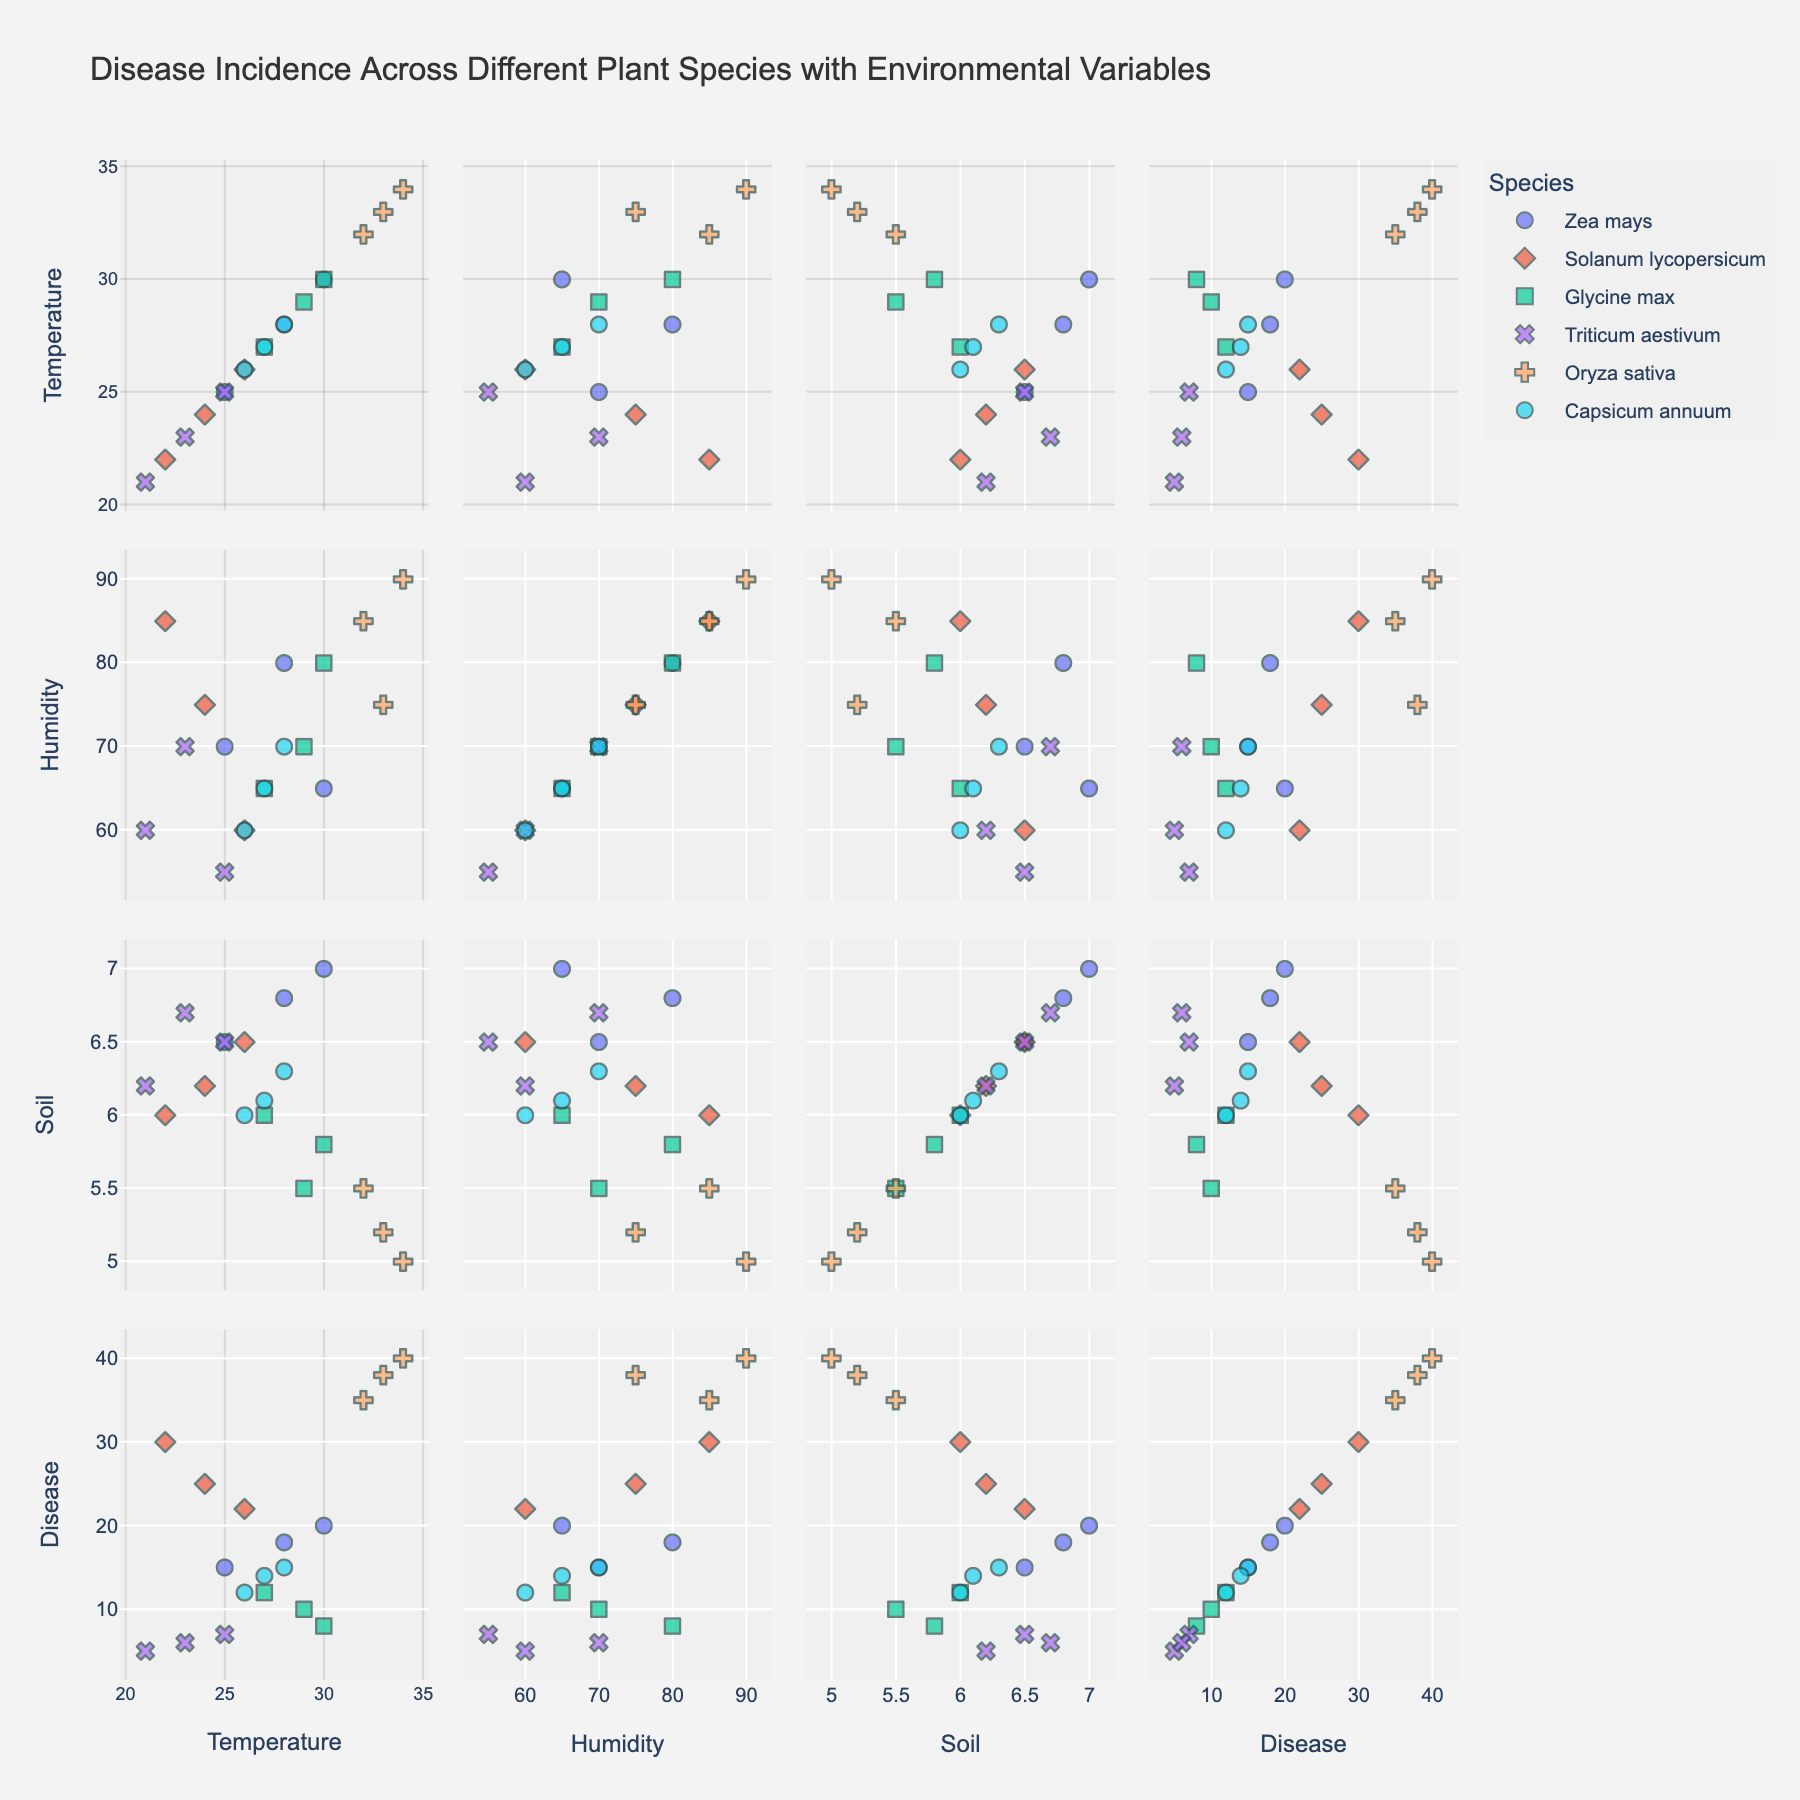What's the title of the figure? Look at the top of the figure to find the title. The title is usually bold and centered above the plot area.
Answer: Disease Incidence Across Different Plant Species with Environmental Variables How many plant species are being compared in the plot? Look at the legend to identify the distinct groups or plant species listed. Count the number of unique species in the legend.
Answer: 6 Which variable tends to have the highest variance across all species? Observe each scatter plot of the SPLOM and check which variable's values are most spread out vertically or horizontally. This gives an indication of which variable has the highest variance.
Answer: Temperature (°C) Which species shows the highest disease incidence (%)? Look at the scatter matrix in the "Disease Incidence (%)" row and column. Notice which species' data points have the highest values on the y-axis.
Answer: Oryza sativa Is there a general relationship between humidity (%) and disease incidence (%)? Observe the scatter plot that compares Humidity (%) and Disease Incidence (%). Look for any visible pattern or trend, such as data points forming an upward or downward line.
Answer: Yes, the disease incidence increases with humidity Which species has the lowest average soil pH value? Observe the scatter plots showing soil pH values for each species. Identify the species that consistently has the lower data points.
Answer: Glycine max How does the disease incidence of Triticum aestivum compare to Solanum lycopersicum under similar humidity levels? Look for data points of Triticum aestivum and Solanum lycopersicum in the scatter plots comparing Humidity (%) and Disease Incidence (%), and compare their y-values for similar x-values of Humidity (%).
Answer: Triticum aestivum has a lower disease incidence Which two species have overlapping data points in terms of humidity and disease incidence? Examine the scatter plot for Humidity (%) vs. Disease Incidence (%) and look for clusters of data points from different species that are close to each other.
Answer: Zea mays and Capsicum annuum Which environmental variable has the least influence on disease incidence for Zea mays? Compare the scatter plots involving Zea mays for each environmental variable (Temperature, Humidity, and Soil pH) against Disease Incidence (%) and look for the one with the least obvious trend or pattern.
Answer: Soil pH For Glycine max, is there more variation in disease incidence at higher or lower temperature values? Look at Glycine max data points in the scatter plots involving Temperature (°C) and Disease Incidence (%). Notice if the spread of values is more at higher or lower temperatures.
Answer: Lower temperature values 